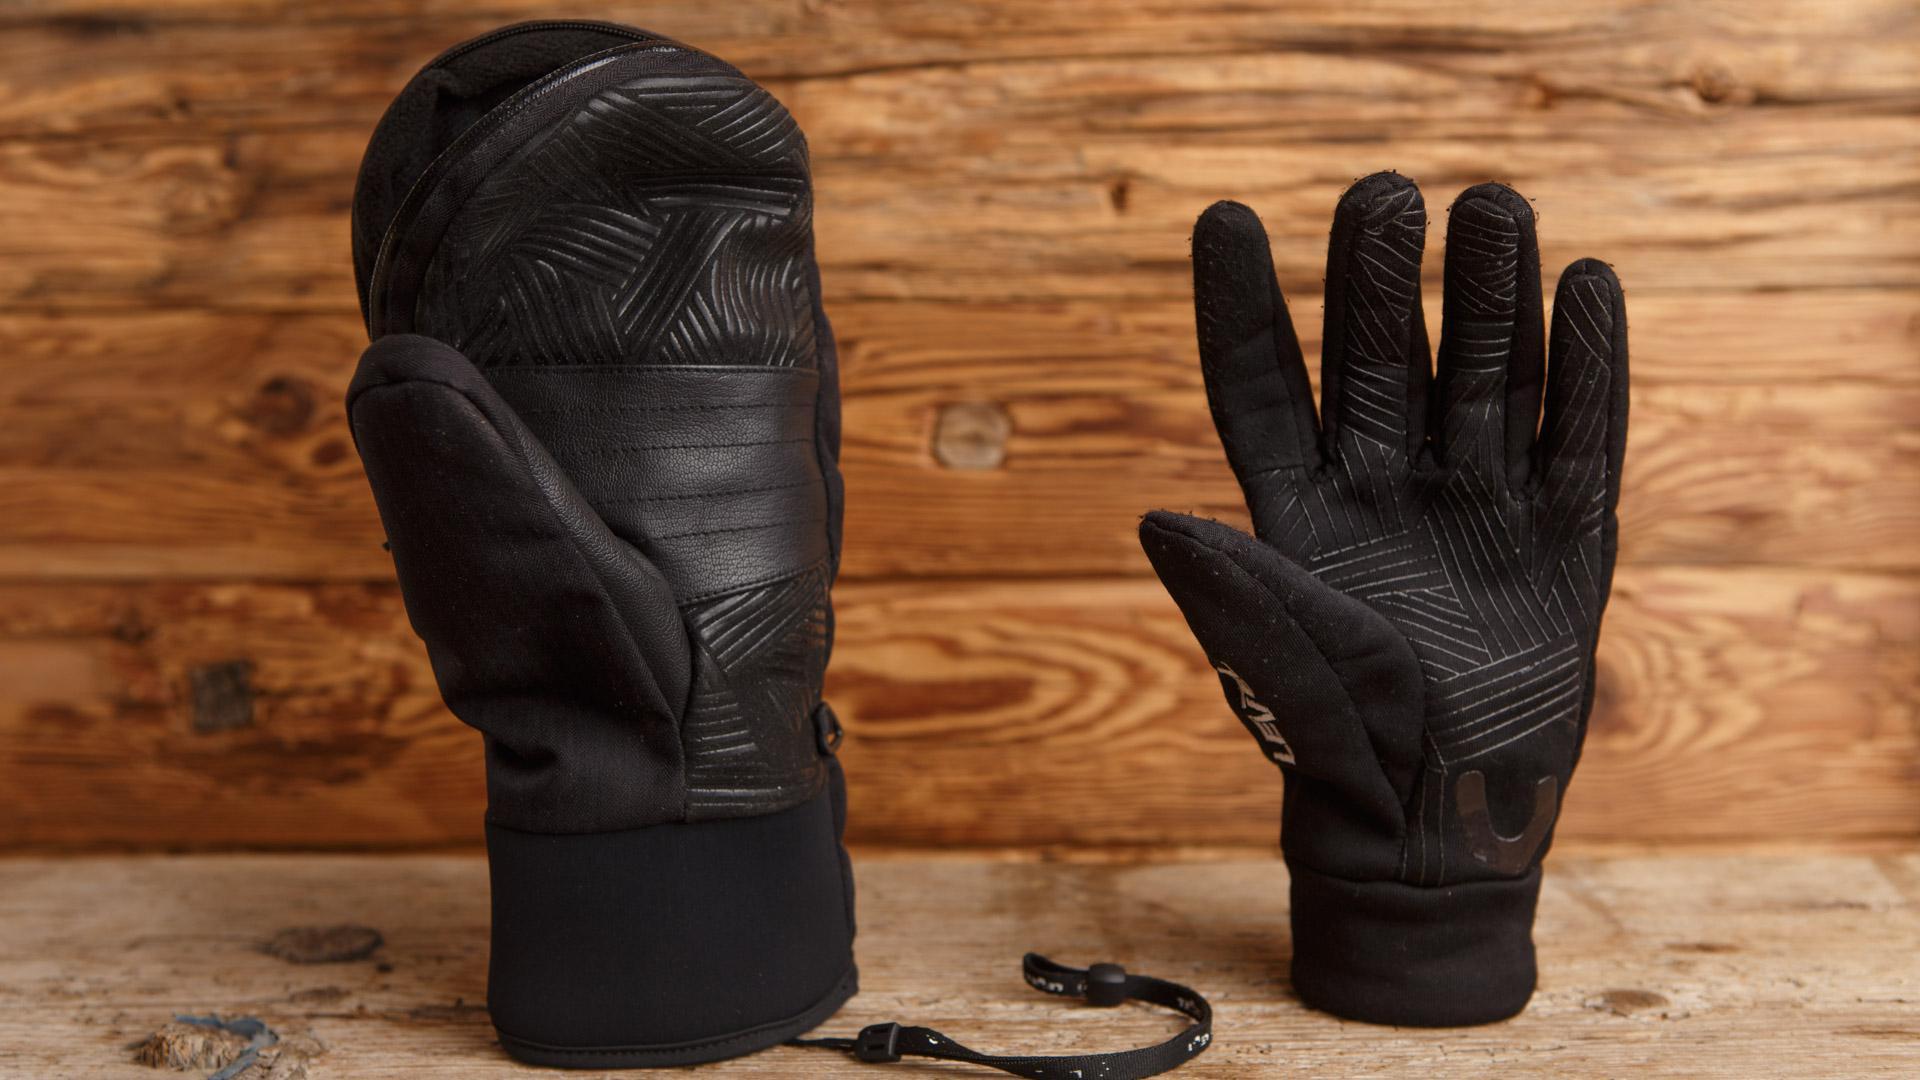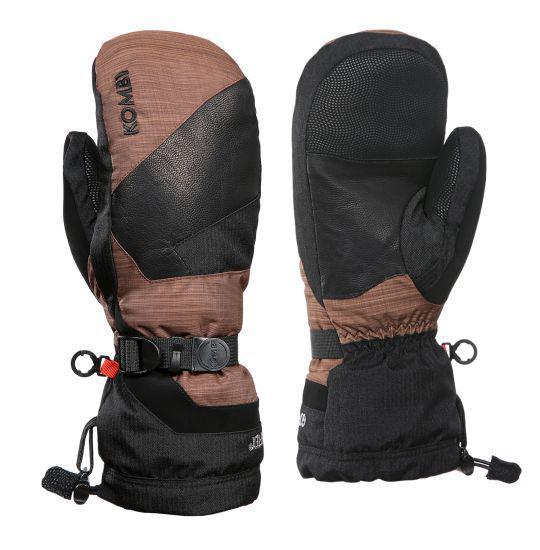The first image is the image on the left, the second image is the image on the right. For the images displayed, is the sentence "One image shows a matched pair of mittens, and the other image includes a glove with fingers." factually correct? Answer yes or no. Yes. The first image is the image on the left, the second image is the image on the right. Examine the images to the left and right. Is the description "A glove with individual fingers is visible." accurate? Answer yes or no. Yes. 